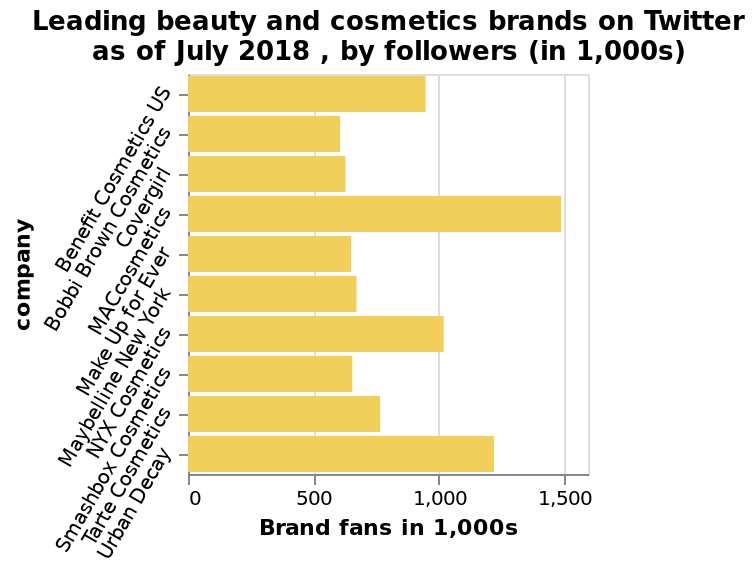<image>
What is the range of the x-axis on the bar diagram?  The range of the x-axis on the bar diagram is 0 to 1,500. please summary the statistics and relations of the chart The leading brand plotted is Mac Cosmetics. The least popular brand plotted is Bobbi Brown Cosmetics. What is represented on the y-axis of the bar diagram? The y-axis of the bar diagram represents the company. 